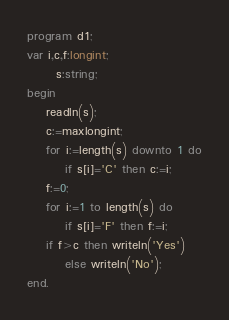Convert code to text. <code><loc_0><loc_0><loc_500><loc_500><_Pascal_>program d1;
var i,c,f:longint;
      s:string;
begin
    readln(s);
	c:=maxlongint;
	for i:=length(s) downto 1 do
		if s[i]='C' then c:=i;
	f:=0;
	for i:=1 to length(s) do
		if s[i]='F' then f:=i;
	if f>c then writeln('Yes')
		else writeln('No');
end. </code> 